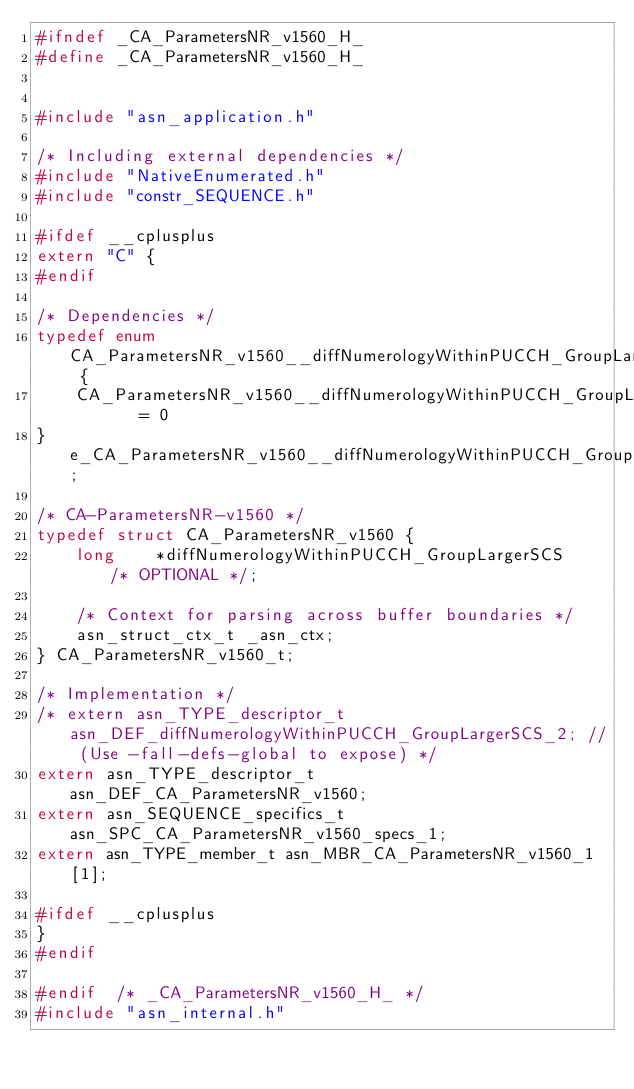<code> <loc_0><loc_0><loc_500><loc_500><_C_>#ifndef	_CA_ParametersNR_v1560_H_
#define	_CA_ParametersNR_v1560_H_


#include "asn_application.h"

/* Including external dependencies */
#include "NativeEnumerated.h"
#include "constr_SEQUENCE.h"

#ifdef __cplusplus
extern "C" {
#endif

/* Dependencies */
typedef enum CA_ParametersNR_v1560__diffNumerologyWithinPUCCH_GroupLargerSCS {
	CA_ParametersNR_v1560__diffNumerologyWithinPUCCH_GroupLargerSCS_supported	= 0
} e_CA_ParametersNR_v1560__diffNumerologyWithinPUCCH_GroupLargerSCS;

/* CA-ParametersNR-v1560 */
typedef struct CA_ParametersNR_v1560 {
	long	*diffNumerologyWithinPUCCH_GroupLargerSCS	/* OPTIONAL */;
	
	/* Context for parsing across buffer boundaries */
	asn_struct_ctx_t _asn_ctx;
} CA_ParametersNR_v1560_t;

/* Implementation */
/* extern asn_TYPE_descriptor_t asn_DEF_diffNumerologyWithinPUCCH_GroupLargerSCS_2;	// (Use -fall-defs-global to expose) */
extern asn_TYPE_descriptor_t asn_DEF_CA_ParametersNR_v1560;
extern asn_SEQUENCE_specifics_t asn_SPC_CA_ParametersNR_v1560_specs_1;
extern asn_TYPE_member_t asn_MBR_CA_ParametersNR_v1560_1[1];

#ifdef __cplusplus
}
#endif

#endif	/* _CA_ParametersNR_v1560_H_ */
#include "asn_internal.h"
</code> 